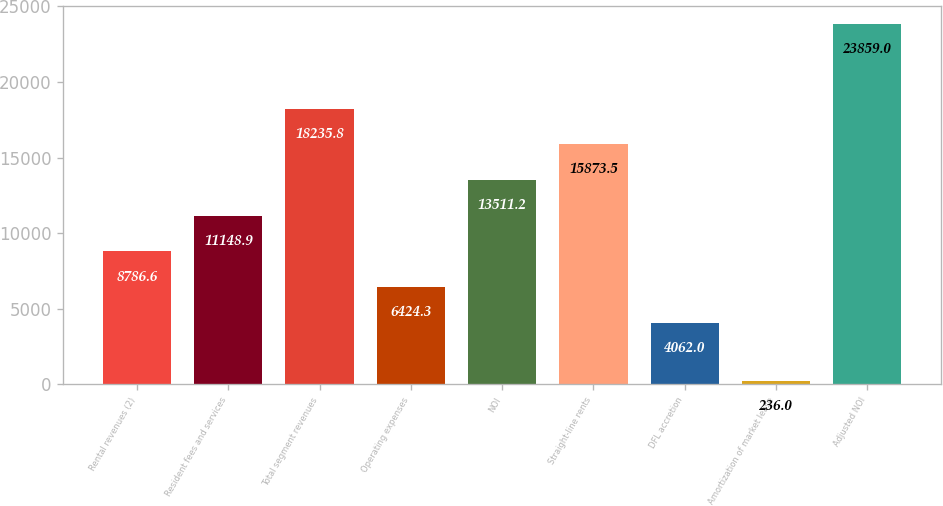Convert chart. <chart><loc_0><loc_0><loc_500><loc_500><bar_chart><fcel>Rental revenues (2)<fcel>Resident fees and services<fcel>Total segment revenues<fcel>Operating expenses<fcel>NOI<fcel>Straight-line rents<fcel>DFL accretion<fcel>Amortization of market lease<fcel>Adjusted NOI<nl><fcel>8786.6<fcel>11148.9<fcel>18235.8<fcel>6424.3<fcel>13511.2<fcel>15873.5<fcel>4062<fcel>236<fcel>23859<nl></chart> 